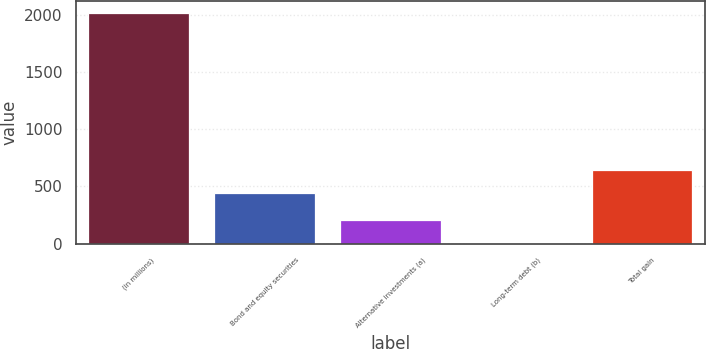Convert chart. <chart><loc_0><loc_0><loc_500><loc_500><bar_chart><fcel>(in millions)<fcel>Bond and equity securities<fcel>Alternative investments (a)<fcel>Long-term debt (b)<fcel>Total gain<nl><fcel>2016<fcel>447<fcel>209.7<fcel>9<fcel>647.7<nl></chart> 